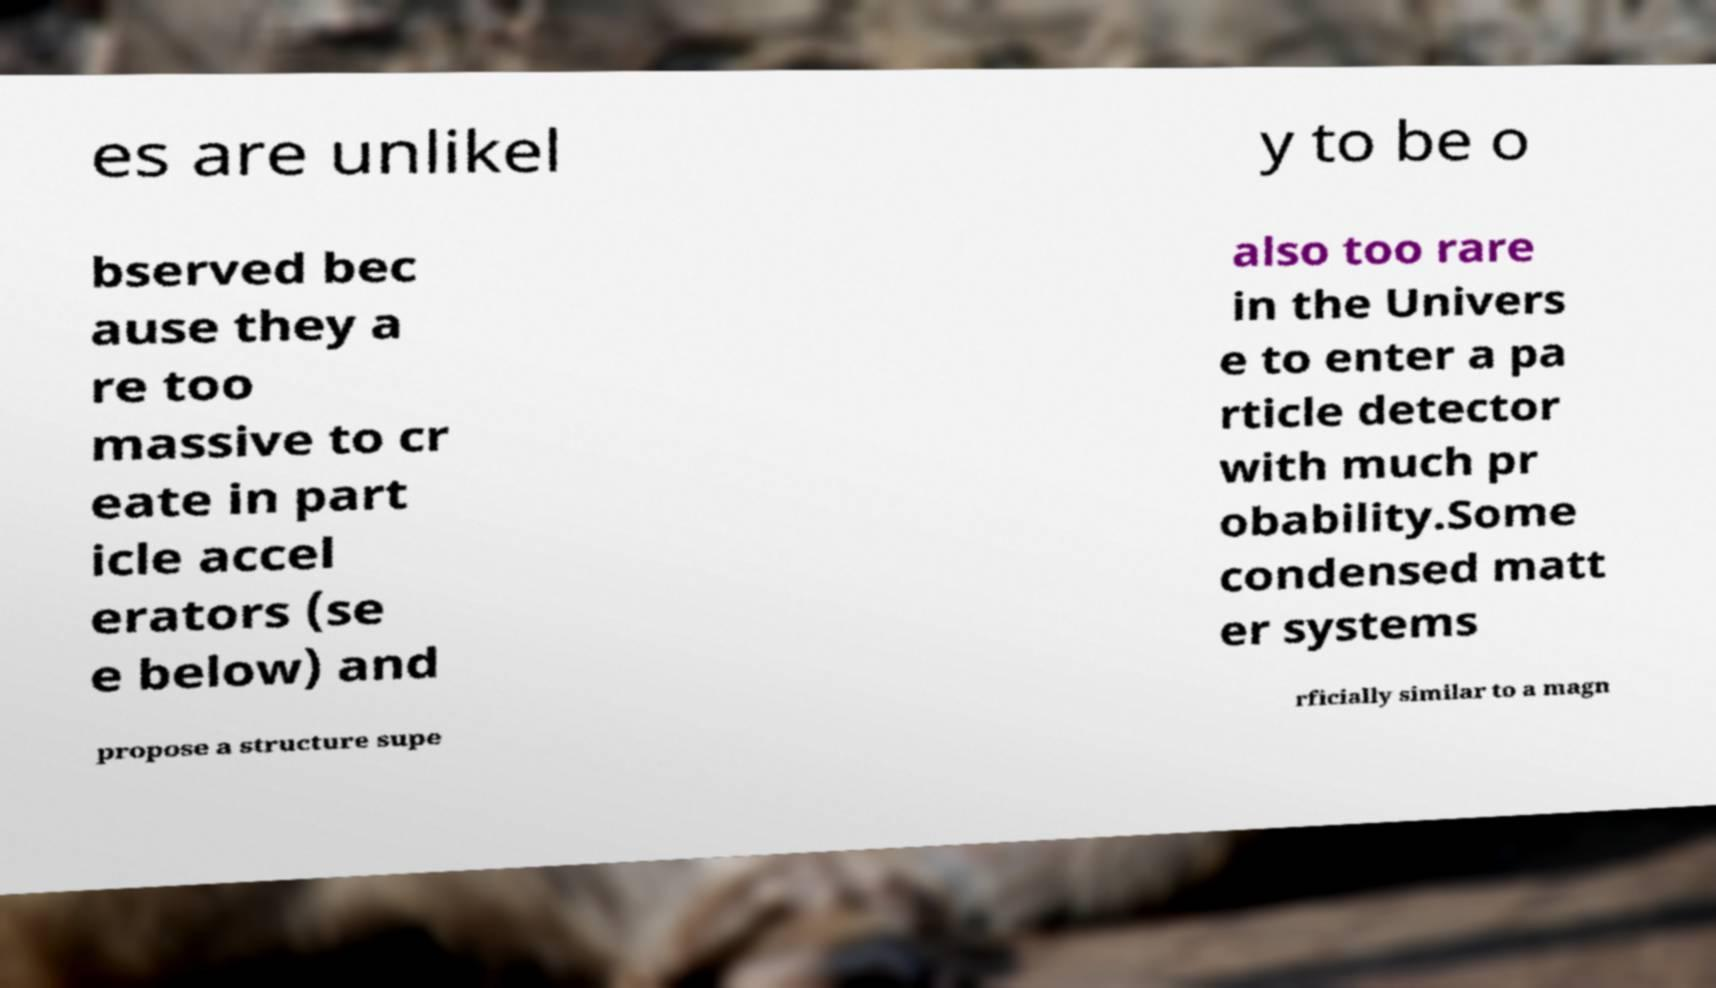Could you extract and type out the text from this image? es are unlikel y to be o bserved bec ause they a re too massive to cr eate in part icle accel erators (se e below) and also too rare in the Univers e to enter a pa rticle detector with much pr obability.Some condensed matt er systems propose a structure supe rficially similar to a magn 